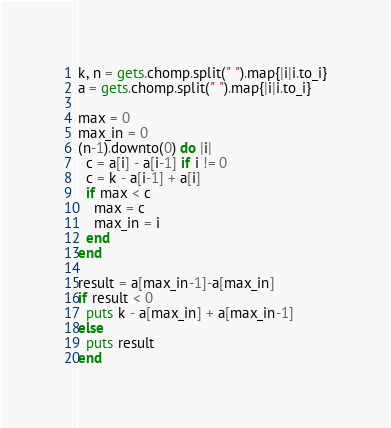Convert code to text. <code><loc_0><loc_0><loc_500><loc_500><_Ruby_>k, n = gets.chomp.split(" ").map{|i|i.to_i}
a = gets.chomp.split(" ").map{|i|i.to_i}

max = 0
max_in = 0
(n-1).downto(0) do |i|
  c = a[i] - a[i-1] if i != 0
  c = k - a[i-1] + a[i]
  if max < c
    max = c
    max_in = i
  end
end

result = a[max_in-1]-a[max_in]
if result < 0
  puts k - a[max_in] + a[max_in-1]
else
  puts result
end</code> 